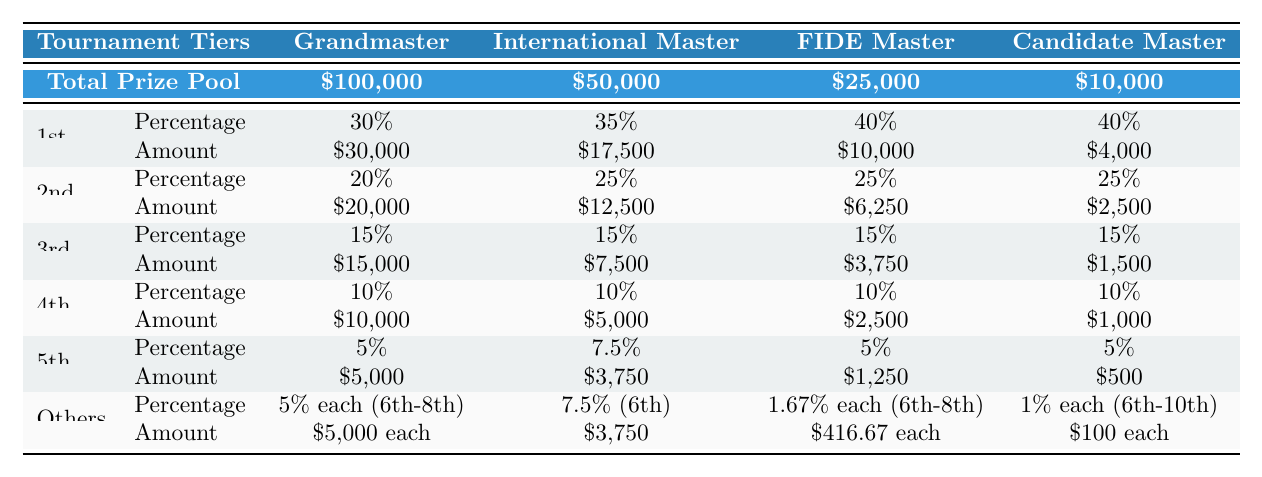What is the total prize pool for the Grandmaster tier? The total prize pool for the Grandmaster tier is explicitly stated in the table as $100,000.
Answer: $100,000 How much does the 2nd place winner in the FIDE Master tier receive? The amount for the 2nd place winner in the FIDE Master tier is listed in the corresponding row as $6,250.
Answer: $6,250 What percentage of the total prize pool does the 1st place winner in the International Master tier receive? The percentage for the 1st place winner in the International Master tier is indicated in the table as 35%.
Answer: 35% Which tier has the highest individual prize for the 3rd place? Checking the amounts for the 3rd place across all tiers shows that the Grandmaster tier has the highest individual prize of $15,000.
Answer: Grandmaster If a player finishes in 6th place in the Candidate Master tier, how much will they earn? According to the table, players in the 6th place receive $100 each in the Candidate Master tier.
Answer: $100 What is the total amount awarded to the top three players in the FIDE Master tier? The total can be calculated by adding the amounts for the top three positions: $10,000 (1st) + $6,250 (2nd) + $3,750 (3rd) = $20,000.
Answer: $20,000 Is the percentage for the 5th place winner in the Grandmaster tier the same amount each for the 5th to 8th position? Yes, the table states that the 5th to 8th position receives 5% each, indicating they all receive the same percentage.
Answer: Yes What is the total percentage distribution for places 1 through 4 in the International Master tier? The sum of the percentages for places 1 to 4 is: 35% (1st) + 25% (2nd) + 15% (3rd) + 10% (4th) = 85%.
Answer: 85% Which tier’s 2nd place prize is equal to the 5th place prize in the FIDE Master tier? The 2nd place prize in the Candidate Master tier is $2,500, which is equal to the 5th place prize in the FIDE Master tier at $1,250.
Answer: Candidate Master How much less does the 1st place in the FIDE Master tier earn compared to the 1st place in the Grandmaster tier? The difference can be calculated as $30,000 (Grandmaster) - $10,000 (FIDE Master) = $20,000.
Answer: $20,000 